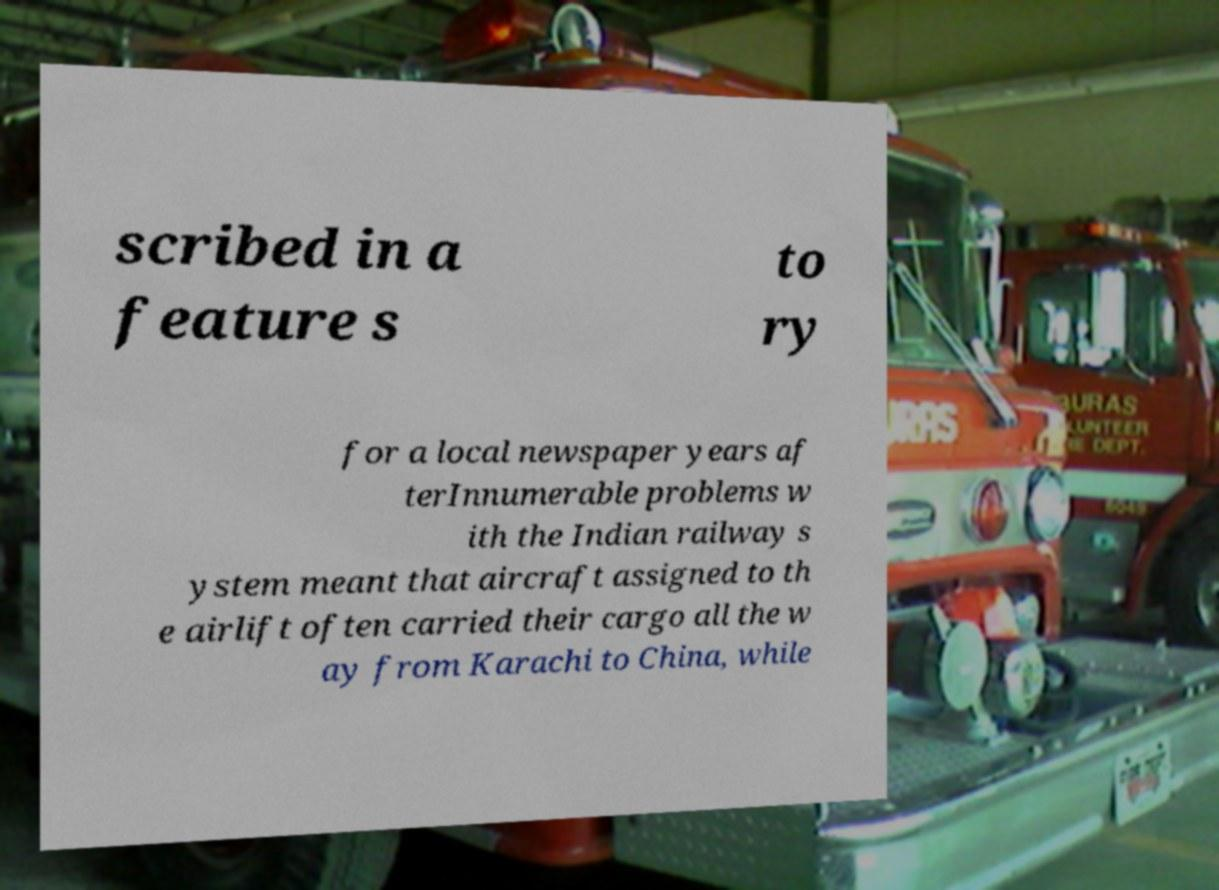Can you read and provide the text displayed in the image?This photo seems to have some interesting text. Can you extract and type it out for me? scribed in a feature s to ry for a local newspaper years af terInnumerable problems w ith the Indian railway s ystem meant that aircraft assigned to th e airlift often carried their cargo all the w ay from Karachi to China, while 